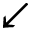Convert formula to latex. <formula><loc_0><loc_0><loc_500><loc_500>\swarrow</formula> 